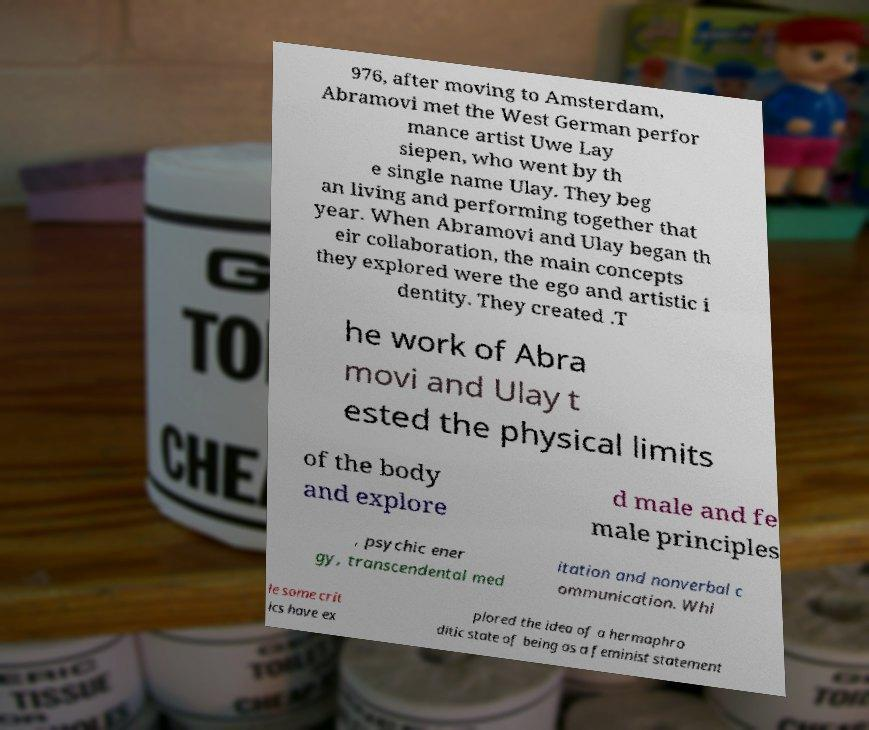I need the written content from this picture converted into text. Can you do that? 976, after moving to Amsterdam, Abramovi met the West German perfor mance artist Uwe Lay siepen, who went by th e single name Ulay. They beg an living and performing together that year. When Abramovi and Ulay began th eir collaboration, the main concepts they explored were the ego and artistic i dentity. They created .T he work of Abra movi and Ulay t ested the physical limits of the body and explore d male and fe male principles , psychic ener gy, transcendental med itation and nonverbal c ommunication. Whi le some crit ics have ex plored the idea of a hermaphro ditic state of being as a feminist statement 